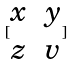<formula> <loc_0><loc_0><loc_500><loc_500>[ \begin{matrix} x & y \\ z & v \end{matrix} ]</formula> 